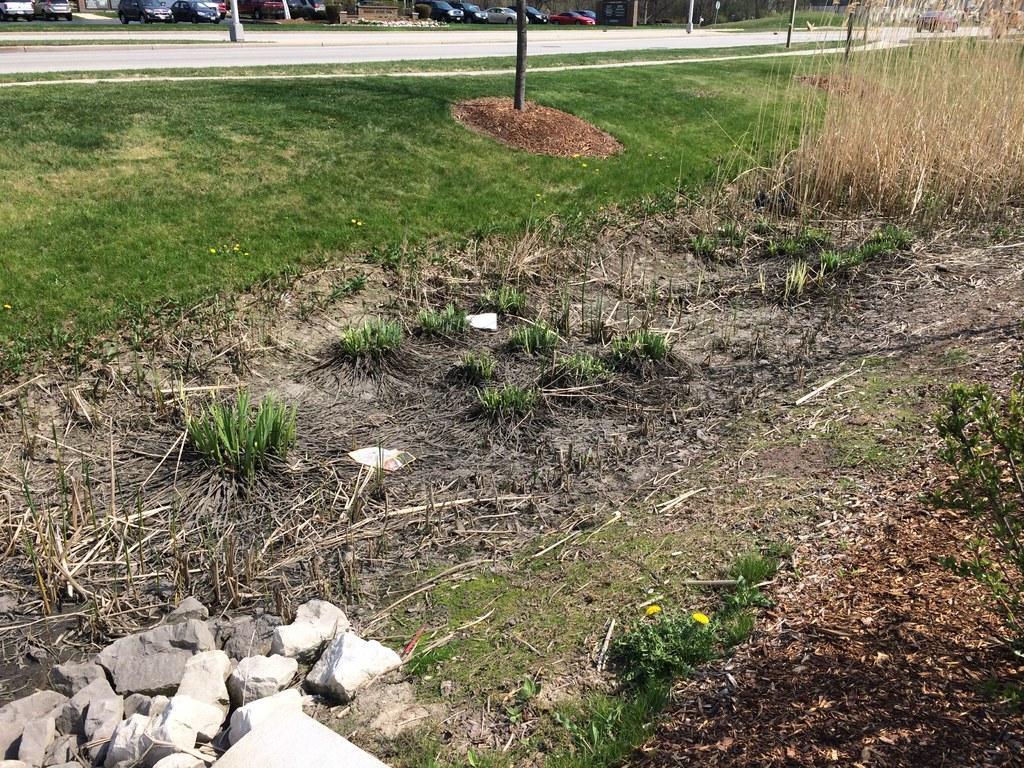Please provide a concise description of this image. This picture is taken from the outside of the city. In this image, in the middle, we can see a wood pole. In the background, we can also see a pole and some cars. On the left side, we can also see a car which is placed on the road. At the bottom, we can see some plants and a grass. In the left corner, we can also see some stones. 